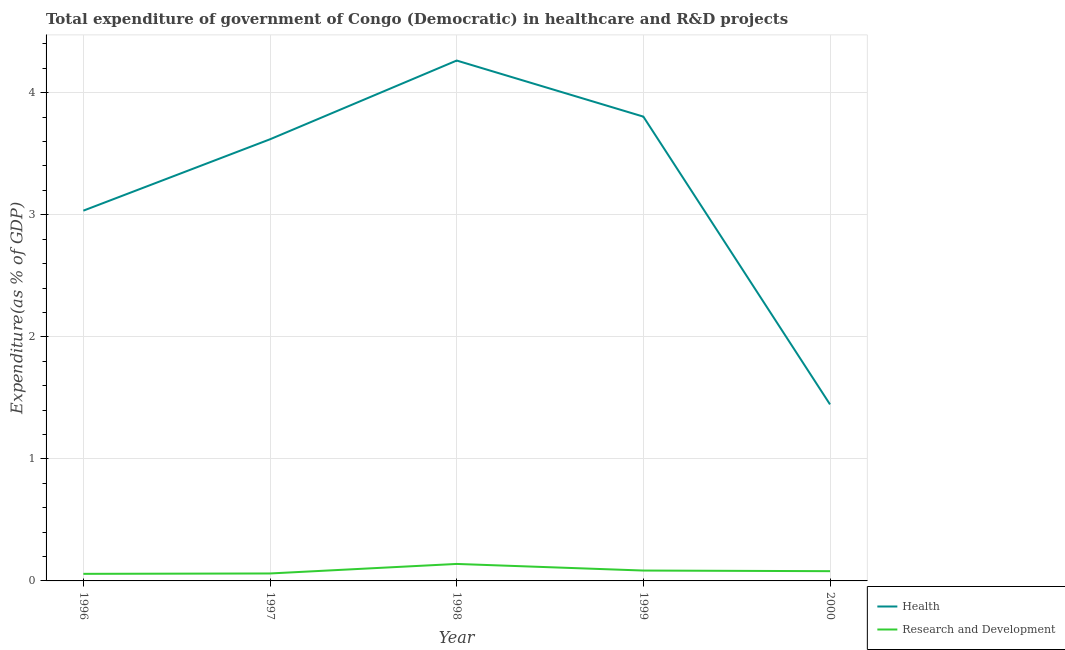What is the expenditure in r&d in 2000?
Offer a terse response. 0.08. Across all years, what is the maximum expenditure in r&d?
Give a very brief answer. 0.14. Across all years, what is the minimum expenditure in healthcare?
Provide a succinct answer. 1.45. In which year was the expenditure in r&d maximum?
Keep it short and to the point. 1998. What is the total expenditure in r&d in the graph?
Your response must be concise. 0.42. What is the difference between the expenditure in healthcare in 1997 and that in 2000?
Offer a very short reply. 2.17. What is the difference between the expenditure in healthcare in 1996 and the expenditure in r&d in 1999?
Your response must be concise. 2.95. What is the average expenditure in healthcare per year?
Provide a succinct answer. 3.23. In the year 1996, what is the difference between the expenditure in r&d and expenditure in healthcare?
Give a very brief answer. -2.98. In how many years, is the expenditure in r&d greater than 0.6000000000000001 %?
Offer a terse response. 0. What is the ratio of the expenditure in r&d in 1997 to that in 1998?
Offer a terse response. 0.44. Is the expenditure in r&d in 1997 less than that in 1998?
Make the answer very short. Yes. What is the difference between the highest and the second highest expenditure in r&d?
Keep it short and to the point. 0.05. What is the difference between the highest and the lowest expenditure in healthcare?
Your response must be concise. 2.82. Does the expenditure in r&d monotonically increase over the years?
Your answer should be compact. No. Is the expenditure in r&d strictly less than the expenditure in healthcare over the years?
Your response must be concise. Yes. How many lines are there?
Your response must be concise. 2. How many years are there in the graph?
Ensure brevity in your answer.  5. Are the values on the major ticks of Y-axis written in scientific E-notation?
Offer a terse response. No. Does the graph contain any zero values?
Keep it short and to the point. No. Does the graph contain grids?
Offer a terse response. Yes. Where does the legend appear in the graph?
Your response must be concise. Bottom right. How many legend labels are there?
Ensure brevity in your answer.  2. How are the legend labels stacked?
Your answer should be compact. Vertical. What is the title of the graph?
Make the answer very short. Total expenditure of government of Congo (Democratic) in healthcare and R&D projects. What is the label or title of the X-axis?
Your answer should be compact. Year. What is the label or title of the Y-axis?
Make the answer very short. Expenditure(as % of GDP). What is the Expenditure(as % of GDP) of Health in 1996?
Ensure brevity in your answer.  3.03. What is the Expenditure(as % of GDP) of Research and Development in 1996?
Your answer should be compact. 0.06. What is the Expenditure(as % of GDP) of Health in 1997?
Your answer should be very brief. 3.62. What is the Expenditure(as % of GDP) of Research and Development in 1997?
Provide a succinct answer. 0.06. What is the Expenditure(as % of GDP) in Health in 1998?
Provide a succinct answer. 4.26. What is the Expenditure(as % of GDP) of Research and Development in 1998?
Provide a short and direct response. 0.14. What is the Expenditure(as % of GDP) in Health in 1999?
Provide a short and direct response. 3.8. What is the Expenditure(as % of GDP) of Research and Development in 1999?
Your response must be concise. 0.09. What is the Expenditure(as % of GDP) in Health in 2000?
Your answer should be very brief. 1.45. What is the Expenditure(as % of GDP) in Research and Development in 2000?
Offer a very short reply. 0.08. Across all years, what is the maximum Expenditure(as % of GDP) in Health?
Provide a succinct answer. 4.26. Across all years, what is the maximum Expenditure(as % of GDP) in Research and Development?
Your response must be concise. 0.14. Across all years, what is the minimum Expenditure(as % of GDP) in Health?
Make the answer very short. 1.45. Across all years, what is the minimum Expenditure(as % of GDP) of Research and Development?
Offer a terse response. 0.06. What is the total Expenditure(as % of GDP) in Health in the graph?
Ensure brevity in your answer.  16.17. What is the total Expenditure(as % of GDP) of Research and Development in the graph?
Provide a short and direct response. 0.42. What is the difference between the Expenditure(as % of GDP) in Health in 1996 and that in 1997?
Your answer should be very brief. -0.58. What is the difference between the Expenditure(as % of GDP) of Research and Development in 1996 and that in 1997?
Give a very brief answer. -0. What is the difference between the Expenditure(as % of GDP) of Health in 1996 and that in 1998?
Provide a succinct answer. -1.23. What is the difference between the Expenditure(as % of GDP) of Research and Development in 1996 and that in 1998?
Give a very brief answer. -0.08. What is the difference between the Expenditure(as % of GDP) of Health in 1996 and that in 1999?
Make the answer very short. -0.77. What is the difference between the Expenditure(as % of GDP) of Research and Development in 1996 and that in 1999?
Keep it short and to the point. -0.03. What is the difference between the Expenditure(as % of GDP) of Health in 1996 and that in 2000?
Make the answer very short. 1.59. What is the difference between the Expenditure(as % of GDP) of Research and Development in 1996 and that in 2000?
Give a very brief answer. -0.02. What is the difference between the Expenditure(as % of GDP) in Health in 1997 and that in 1998?
Your response must be concise. -0.65. What is the difference between the Expenditure(as % of GDP) of Research and Development in 1997 and that in 1998?
Make the answer very short. -0.08. What is the difference between the Expenditure(as % of GDP) of Health in 1997 and that in 1999?
Your answer should be compact. -0.19. What is the difference between the Expenditure(as % of GDP) in Research and Development in 1997 and that in 1999?
Make the answer very short. -0.02. What is the difference between the Expenditure(as % of GDP) of Health in 1997 and that in 2000?
Ensure brevity in your answer.  2.17. What is the difference between the Expenditure(as % of GDP) of Research and Development in 1997 and that in 2000?
Your response must be concise. -0.02. What is the difference between the Expenditure(as % of GDP) of Health in 1998 and that in 1999?
Ensure brevity in your answer.  0.46. What is the difference between the Expenditure(as % of GDP) in Research and Development in 1998 and that in 1999?
Offer a terse response. 0.05. What is the difference between the Expenditure(as % of GDP) in Health in 1998 and that in 2000?
Make the answer very short. 2.82. What is the difference between the Expenditure(as % of GDP) in Research and Development in 1998 and that in 2000?
Your answer should be very brief. 0.06. What is the difference between the Expenditure(as % of GDP) in Health in 1999 and that in 2000?
Your answer should be compact. 2.36. What is the difference between the Expenditure(as % of GDP) in Research and Development in 1999 and that in 2000?
Ensure brevity in your answer.  0.01. What is the difference between the Expenditure(as % of GDP) of Health in 1996 and the Expenditure(as % of GDP) of Research and Development in 1997?
Your response must be concise. 2.97. What is the difference between the Expenditure(as % of GDP) of Health in 1996 and the Expenditure(as % of GDP) of Research and Development in 1998?
Give a very brief answer. 2.89. What is the difference between the Expenditure(as % of GDP) in Health in 1996 and the Expenditure(as % of GDP) in Research and Development in 1999?
Your answer should be compact. 2.95. What is the difference between the Expenditure(as % of GDP) of Health in 1996 and the Expenditure(as % of GDP) of Research and Development in 2000?
Ensure brevity in your answer.  2.95. What is the difference between the Expenditure(as % of GDP) in Health in 1997 and the Expenditure(as % of GDP) in Research and Development in 1998?
Offer a terse response. 3.48. What is the difference between the Expenditure(as % of GDP) of Health in 1997 and the Expenditure(as % of GDP) of Research and Development in 1999?
Ensure brevity in your answer.  3.53. What is the difference between the Expenditure(as % of GDP) of Health in 1997 and the Expenditure(as % of GDP) of Research and Development in 2000?
Make the answer very short. 3.54. What is the difference between the Expenditure(as % of GDP) of Health in 1998 and the Expenditure(as % of GDP) of Research and Development in 1999?
Ensure brevity in your answer.  4.18. What is the difference between the Expenditure(as % of GDP) of Health in 1998 and the Expenditure(as % of GDP) of Research and Development in 2000?
Give a very brief answer. 4.18. What is the difference between the Expenditure(as % of GDP) in Health in 1999 and the Expenditure(as % of GDP) in Research and Development in 2000?
Make the answer very short. 3.72. What is the average Expenditure(as % of GDP) of Health per year?
Make the answer very short. 3.23. What is the average Expenditure(as % of GDP) of Research and Development per year?
Provide a succinct answer. 0.08. In the year 1996, what is the difference between the Expenditure(as % of GDP) in Health and Expenditure(as % of GDP) in Research and Development?
Make the answer very short. 2.98. In the year 1997, what is the difference between the Expenditure(as % of GDP) of Health and Expenditure(as % of GDP) of Research and Development?
Offer a very short reply. 3.56. In the year 1998, what is the difference between the Expenditure(as % of GDP) of Health and Expenditure(as % of GDP) of Research and Development?
Your answer should be very brief. 4.12. In the year 1999, what is the difference between the Expenditure(as % of GDP) of Health and Expenditure(as % of GDP) of Research and Development?
Give a very brief answer. 3.72. In the year 2000, what is the difference between the Expenditure(as % of GDP) of Health and Expenditure(as % of GDP) of Research and Development?
Give a very brief answer. 1.37. What is the ratio of the Expenditure(as % of GDP) of Health in 1996 to that in 1997?
Ensure brevity in your answer.  0.84. What is the ratio of the Expenditure(as % of GDP) in Research and Development in 1996 to that in 1997?
Ensure brevity in your answer.  0.95. What is the ratio of the Expenditure(as % of GDP) in Health in 1996 to that in 1998?
Ensure brevity in your answer.  0.71. What is the ratio of the Expenditure(as % of GDP) in Research and Development in 1996 to that in 1998?
Keep it short and to the point. 0.42. What is the ratio of the Expenditure(as % of GDP) in Health in 1996 to that in 1999?
Provide a short and direct response. 0.8. What is the ratio of the Expenditure(as % of GDP) of Research and Development in 1996 to that in 1999?
Offer a very short reply. 0.68. What is the ratio of the Expenditure(as % of GDP) of Health in 1996 to that in 2000?
Give a very brief answer. 2.1. What is the ratio of the Expenditure(as % of GDP) in Research and Development in 1996 to that in 2000?
Make the answer very short. 0.73. What is the ratio of the Expenditure(as % of GDP) in Health in 1997 to that in 1998?
Make the answer very short. 0.85. What is the ratio of the Expenditure(as % of GDP) in Research and Development in 1997 to that in 1998?
Keep it short and to the point. 0.44. What is the ratio of the Expenditure(as % of GDP) of Health in 1997 to that in 1999?
Offer a terse response. 0.95. What is the ratio of the Expenditure(as % of GDP) in Research and Development in 1997 to that in 1999?
Keep it short and to the point. 0.72. What is the ratio of the Expenditure(as % of GDP) in Health in 1997 to that in 2000?
Your answer should be very brief. 2.5. What is the ratio of the Expenditure(as % of GDP) of Research and Development in 1997 to that in 2000?
Your answer should be compact. 0.77. What is the ratio of the Expenditure(as % of GDP) of Health in 1998 to that in 1999?
Offer a terse response. 1.12. What is the ratio of the Expenditure(as % of GDP) of Research and Development in 1998 to that in 1999?
Ensure brevity in your answer.  1.64. What is the ratio of the Expenditure(as % of GDP) in Health in 1998 to that in 2000?
Provide a succinct answer. 2.95. What is the ratio of the Expenditure(as % of GDP) in Research and Development in 1998 to that in 2000?
Give a very brief answer. 1.74. What is the ratio of the Expenditure(as % of GDP) of Health in 1999 to that in 2000?
Provide a short and direct response. 2.63. What is the ratio of the Expenditure(as % of GDP) of Research and Development in 1999 to that in 2000?
Offer a very short reply. 1.06. What is the difference between the highest and the second highest Expenditure(as % of GDP) in Health?
Provide a succinct answer. 0.46. What is the difference between the highest and the second highest Expenditure(as % of GDP) in Research and Development?
Your answer should be compact. 0.05. What is the difference between the highest and the lowest Expenditure(as % of GDP) of Health?
Provide a succinct answer. 2.82. What is the difference between the highest and the lowest Expenditure(as % of GDP) in Research and Development?
Offer a very short reply. 0.08. 